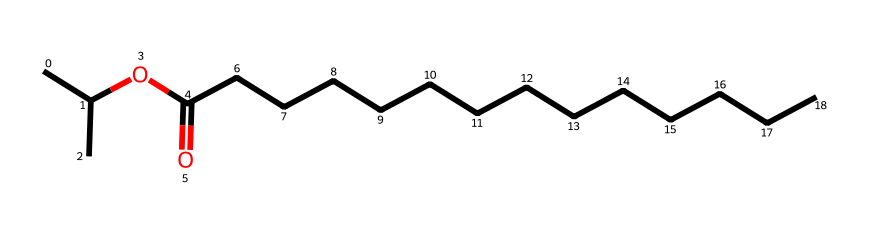What is the molecular formula of isopropyl myristate? By analyzing the structure represented by the SMILES, we can identify the various atoms present. The structure contains three carbon (C) components from the isopropyl group and fourteen carbons from the myristate chain, totaling 17 carbon atoms. There are also 34 hydrogen atoms and 2 oxygen atoms. Thus, the molecular formula can be written as C17H34O2.
Answer: C17H34O2 How many carbon atoms are in isopropyl myristate? Counting from the SMILES representation, there are 17 carbon atoms identified. The isopropyl contributes 3 C's, and the myristate contributes 14 C's, totaling 17.
Answer: 17 What functional groups are present in isopropyl myristate? Looking at the structure, the molecule has an ester functional group, indicated by the -OC(=O)- portion of the SMILES. This suggests that isopropyl myristate is an ester, formed from an alcohol (isopropanol) and a carboxylic acid (myristic acid).
Answer: ester What type of chemical is isopropyl myristate? By considering its structure and functional groups, isopropyl myristate can be classified as an ester. Esters are typically formed from the reaction between an alcohol and a carboxylic acid, which aligns with the structure of isopropyl myristate.
Answer: ester What is the primary use of isopropyl myristate in makeup products? Isopropyl myristate is mainly used as an emollient and solvent in theatrical makeup removers, helping to dissolve makeup and providing a smooth texture on the skin.
Answer: solvent Does isopropyl myristate pose any toxicity risks? Isopropyl myristate is generally considered safe for topical use, but in very high concentrations or with allergic individuals, it can cause skin irritation or sensitization. Therefore, while it’s not highly toxic, caution is advised in its use.
Answer: low toxicity 